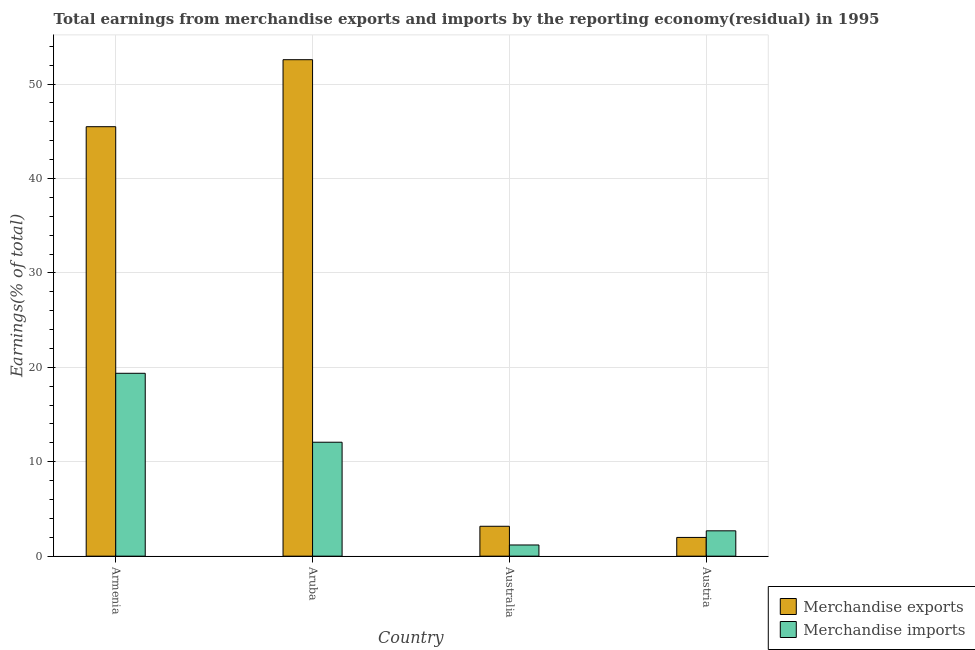How many different coloured bars are there?
Your response must be concise. 2. How many groups of bars are there?
Offer a very short reply. 4. Are the number of bars per tick equal to the number of legend labels?
Provide a succinct answer. Yes. What is the label of the 2nd group of bars from the left?
Ensure brevity in your answer.  Aruba. What is the earnings from merchandise imports in Armenia?
Your answer should be very brief. 19.37. Across all countries, what is the maximum earnings from merchandise exports?
Provide a succinct answer. 52.58. Across all countries, what is the minimum earnings from merchandise imports?
Your answer should be very brief. 1.18. In which country was the earnings from merchandise exports maximum?
Provide a succinct answer. Aruba. In which country was the earnings from merchandise exports minimum?
Make the answer very short. Austria. What is the total earnings from merchandise imports in the graph?
Your answer should be very brief. 35.31. What is the difference between the earnings from merchandise exports in Armenia and that in Australia?
Offer a very short reply. 42.32. What is the difference between the earnings from merchandise exports in Australia and the earnings from merchandise imports in Armenia?
Keep it short and to the point. -16.2. What is the average earnings from merchandise imports per country?
Ensure brevity in your answer.  8.83. What is the difference between the earnings from merchandise imports and earnings from merchandise exports in Aruba?
Your answer should be very brief. -40.51. What is the ratio of the earnings from merchandise exports in Australia to that in Austria?
Give a very brief answer. 1.6. What is the difference between the highest and the second highest earnings from merchandise imports?
Provide a succinct answer. 7.3. What is the difference between the highest and the lowest earnings from merchandise exports?
Provide a succinct answer. 50.59. How many bars are there?
Give a very brief answer. 8. Does the graph contain any zero values?
Offer a terse response. No. Where does the legend appear in the graph?
Provide a succinct answer. Bottom right. What is the title of the graph?
Provide a succinct answer. Total earnings from merchandise exports and imports by the reporting economy(residual) in 1995. Does "Taxes on exports" appear as one of the legend labels in the graph?
Your answer should be compact. No. What is the label or title of the Y-axis?
Offer a terse response. Earnings(% of total). What is the Earnings(% of total) in Merchandise exports in Armenia?
Your response must be concise. 45.48. What is the Earnings(% of total) in Merchandise imports in Armenia?
Your response must be concise. 19.37. What is the Earnings(% of total) in Merchandise exports in Aruba?
Ensure brevity in your answer.  52.58. What is the Earnings(% of total) of Merchandise imports in Aruba?
Keep it short and to the point. 12.07. What is the Earnings(% of total) in Merchandise exports in Australia?
Ensure brevity in your answer.  3.17. What is the Earnings(% of total) of Merchandise imports in Australia?
Your answer should be very brief. 1.18. What is the Earnings(% of total) in Merchandise exports in Austria?
Offer a very short reply. 1.98. What is the Earnings(% of total) in Merchandise imports in Austria?
Make the answer very short. 2.69. Across all countries, what is the maximum Earnings(% of total) of Merchandise exports?
Your response must be concise. 52.58. Across all countries, what is the maximum Earnings(% of total) in Merchandise imports?
Your answer should be compact. 19.37. Across all countries, what is the minimum Earnings(% of total) of Merchandise exports?
Your response must be concise. 1.98. Across all countries, what is the minimum Earnings(% of total) of Merchandise imports?
Your response must be concise. 1.18. What is the total Earnings(% of total) of Merchandise exports in the graph?
Offer a very short reply. 103.21. What is the total Earnings(% of total) of Merchandise imports in the graph?
Ensure brevity in your answer.  35.31. What is the difference between the Earnings(% of total) in Merchandise exports in Armenia and that in Aruba?
Your answer should be compact. -7.1. What is the difference between the Earnings(% of total) in Merchandise imports in Armenia and that in Aruba?
Your response must be concise. 7.3. What is the difference between the Earnings(% of total) of Merchandise exports in Armenia and that in Australia?
Your response must be concise. 42.32. What is the difference between the Earnings(% of total) in Merchandise imports in Armenia and that in Australia?
Keep it short and to the point. 18.18. What is the difference between the Earnings(% of total) in Merchandise exports in Armenia and that in Austria?
Your answer should be very brief. 43.5. What is the difference between the Earnings(% of total) of Merchandise imports in Armenia and that in Austria?
Offer a terse response. 16.68. What is the difference between the Earnings(% of total) of Merchandise exports in Aruba and that in Australia?
Offer a terse response. 49.41. What is the difference between the Earnings(% of total) in Merchandise imports in Aruba and that in Australia?
Your answer should be compact. 10.88. What is the difference between the Earnings(% of total) in Merchandise exports in Aruba and that in Austria?
Your answer should be very brief. 50.59. What is the difference between the Earnings(% of total) of Merchandise imports in Aruba and that in Austria?
Offer a very short reply. 9.38. What is the difference between the Earnings(% of total) of Merchandise exports in Australia and that in Austria?
Your answer should be compact. 1.18. What is the difference between the Earnings(% of total) in Merchandise imports in Australia and that in Austria?
Make the answer very short. -1.5. What is the difference between the Earnings(% of total) of Merchandise exports in Armenia and the Earnings(% of total) of Merchandise imports in Aruba?
Keep it short and to the point. 33.42. What is the difference between the Earnings(% of total) in Merchandise exports in Armenia and the Earnings(% of total) in Merchandise imports in Australia?
Your answer should be very brief. 44.3. What is the difference between the Earnings(% of total) in Merchandise exports in Armenia and the Earnings(% of total) in Merchandise imports in Austria?
Provide a short and direct response. 42.8. What is the difference between the Earnings(% of total) of Merchandise exports in Aruba and the Earnings(% of total) of Merchandise imports in Australia?
Your answer should be compact. 51.39. What is the difference between the Earnings(% of total) in Merchandise exports in Aruba and the Earnings(% of total) in Merchandise imports in Austria?
Your answer should be compact. 49.89. What is the difference between the Earnings(% of total) of Merchandise exports in Australia and the Earnings(% of total) of Merchandise imports in Austria?
Offer a terse response. 0.48. What is the average Earnings(% of total) in Merchandise exports per country?
Provide a short and direct response. 25.8. What is the average Earnings(% of total) in Merchandise imports per country?
Your answer should be very brief. 8.83. What is the difference between the Earnings(% of total) in Merchandise exports and Earnings(% of total) in Merchandise imports in Armenia?
Offer a terse response. 26.12. What is the difference between the Earnings(% of total) of Merchandise exports and Earnings(% of total) of Merchandise imports in Aruba?
Offer a terse response. 40.51. What is the difference between the Earnings(% of total) in Merchandise exports and Earnings(% of total) in Merchandise imports in Australia?
Provide a short and direct response. 1.98. What is the difference between the Earnings(% of total) in Merchandise exports and Earnings(% of total) in Merchandise imports in Austria?
Keep it short and to the point. -0.7. What is the ratio of the Earnings(% of total) in Merchandise exports in Armenia to that in Aruba?
Ensure brevity in your answer.  0.86. What is the ratio of the Earnings(% of total) of Merchandise imports in Armenia to that in Aruba?
Offer a very short reply. 1.61. What is the ratio of the Earnings(% of total) of Merchandise exports in Armenia to that in Australia?
Provide a short and direct response. 14.36. What is the ratio of the Earnings(% of total) in Merchandise imports in Armenia to that in Australia?
Your answer should be very brief. 16.35. What is the ratio of the Earnings(% of total) of Merchandise exports in Armenia to that in Austria?
Ensure brevity in your answer.  22.92. What is the ratio of the Earnings(% of total) in Merchandise imports in Armenia to that in Austria?
Your answer should be compact. 7.21. What is the ratio of the Earnings(% of total) in Merchandise exports in Aruba to that in Australia?
Keep it short and to the point. 16.6. What is the ratio of the Earnings(% of total) of Merchandise imports in Aruba to that in Australia?
Keep it short and to the point. 10.18. What is the ratio of the Earnings(% of total) in Merchandise exports in Aruba to that in Austria?
Offer a terse response. 26.49. What is the ratio of the Earnings(% of total) of Merchandise imports in Aruba to that in Austria?
Offer a very short reply. 4.49. What is the ratio of the Earnings(% of total) in Merchandise exports in Australia to that in Austria?
Your answer should be compact. 1.6. What is the ratio of the Earnings(% of total) of Merchandise imports in Australia to that in Austria?
Your response must be concise. 0.44. What is the difference between the highest and the second highest Earnings(% of total) of Merchandise exports?
Keep it short and to the point. 7.1. What is the difference between the highest and the second highest Earnings(% of total) of Merchandise imports?
Keep it short and to the point. 7.3. What is the difference between the highest and the lowest Earnings(% of total) in Merchandise exports?
Your answer should be compact. 50.59. What is the difference between the highest and the lowest Earnings(% of total) of Merchandise imports?
Provide a short and direct response. 18.18. 